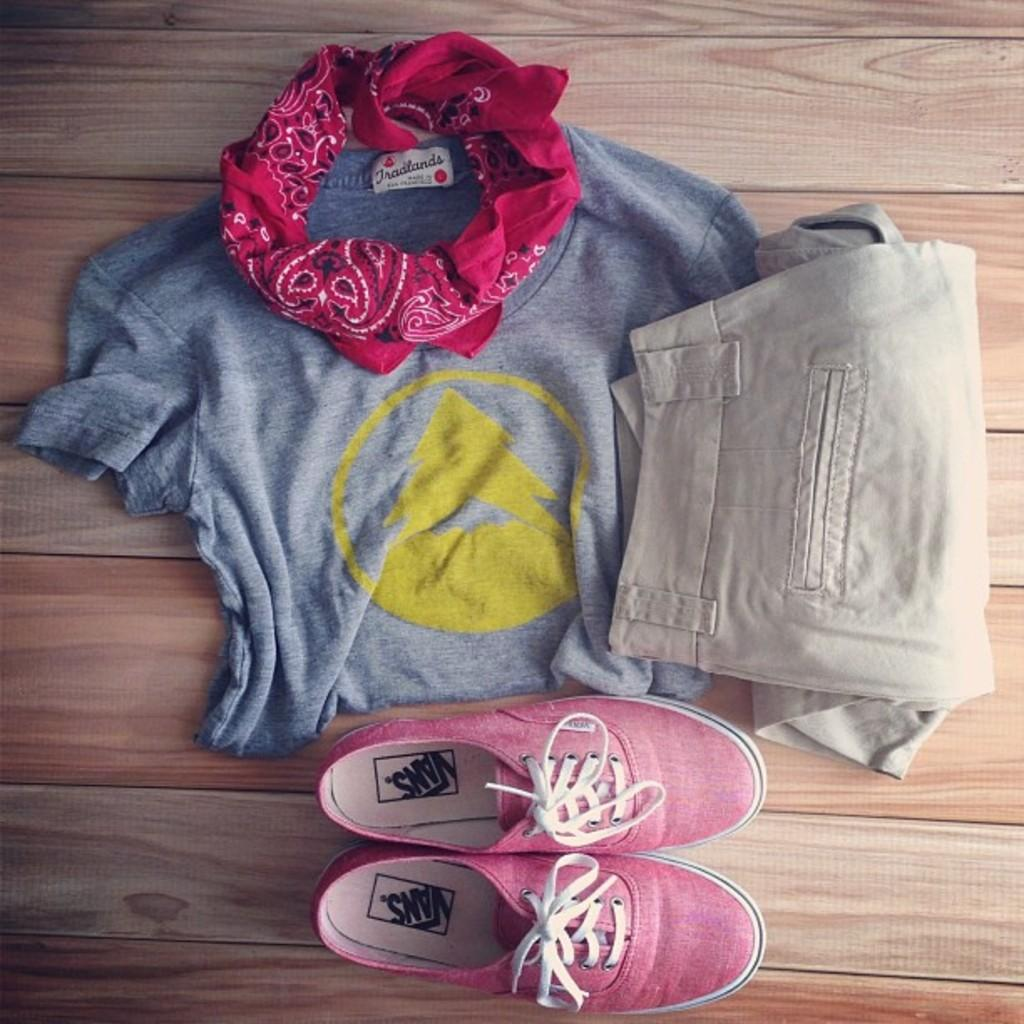What type of items can be seen in the image? There are clothes and shoes in the image. Where are the clothes and shoes located? The clothes and shoes are placed on a wooden surface. What type of toothbrush is visible in the image? There is no toothbrush present in the image. How does the presence of beads affect the appearance of the clothes in the image? There are no beads mentioned in the image, so it is not possible to determine their effect on the appearance of the clothes. 